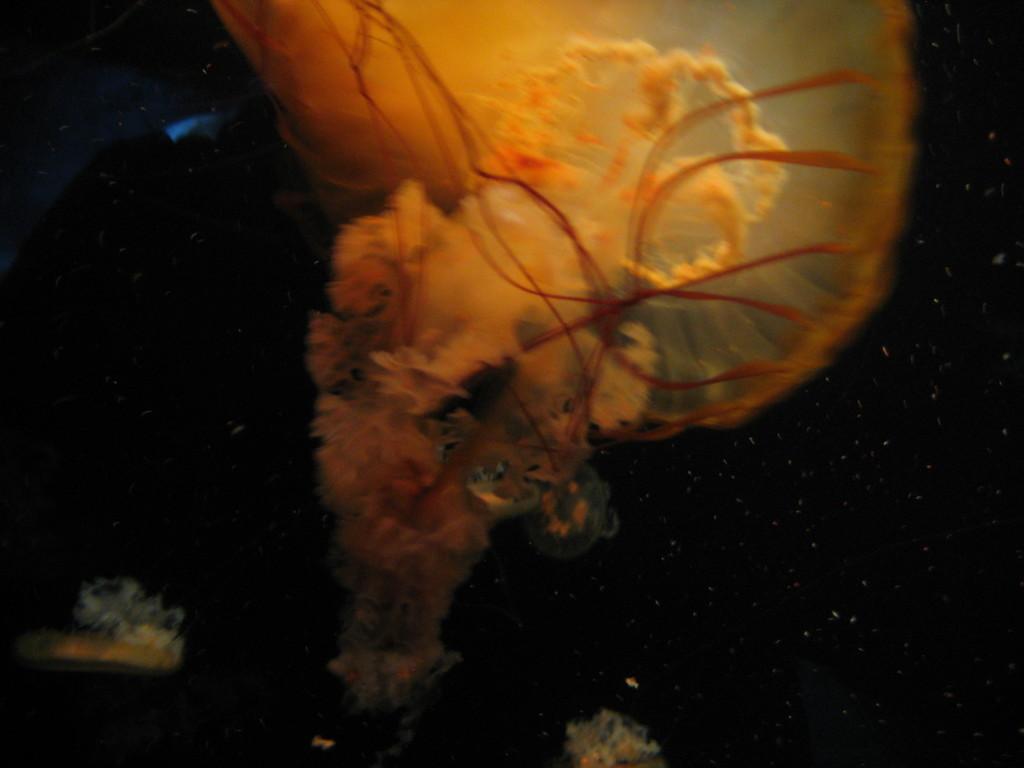In one or two sentences, can you explain what this image depicts? In this image we can see there is a sea creature in the water. 